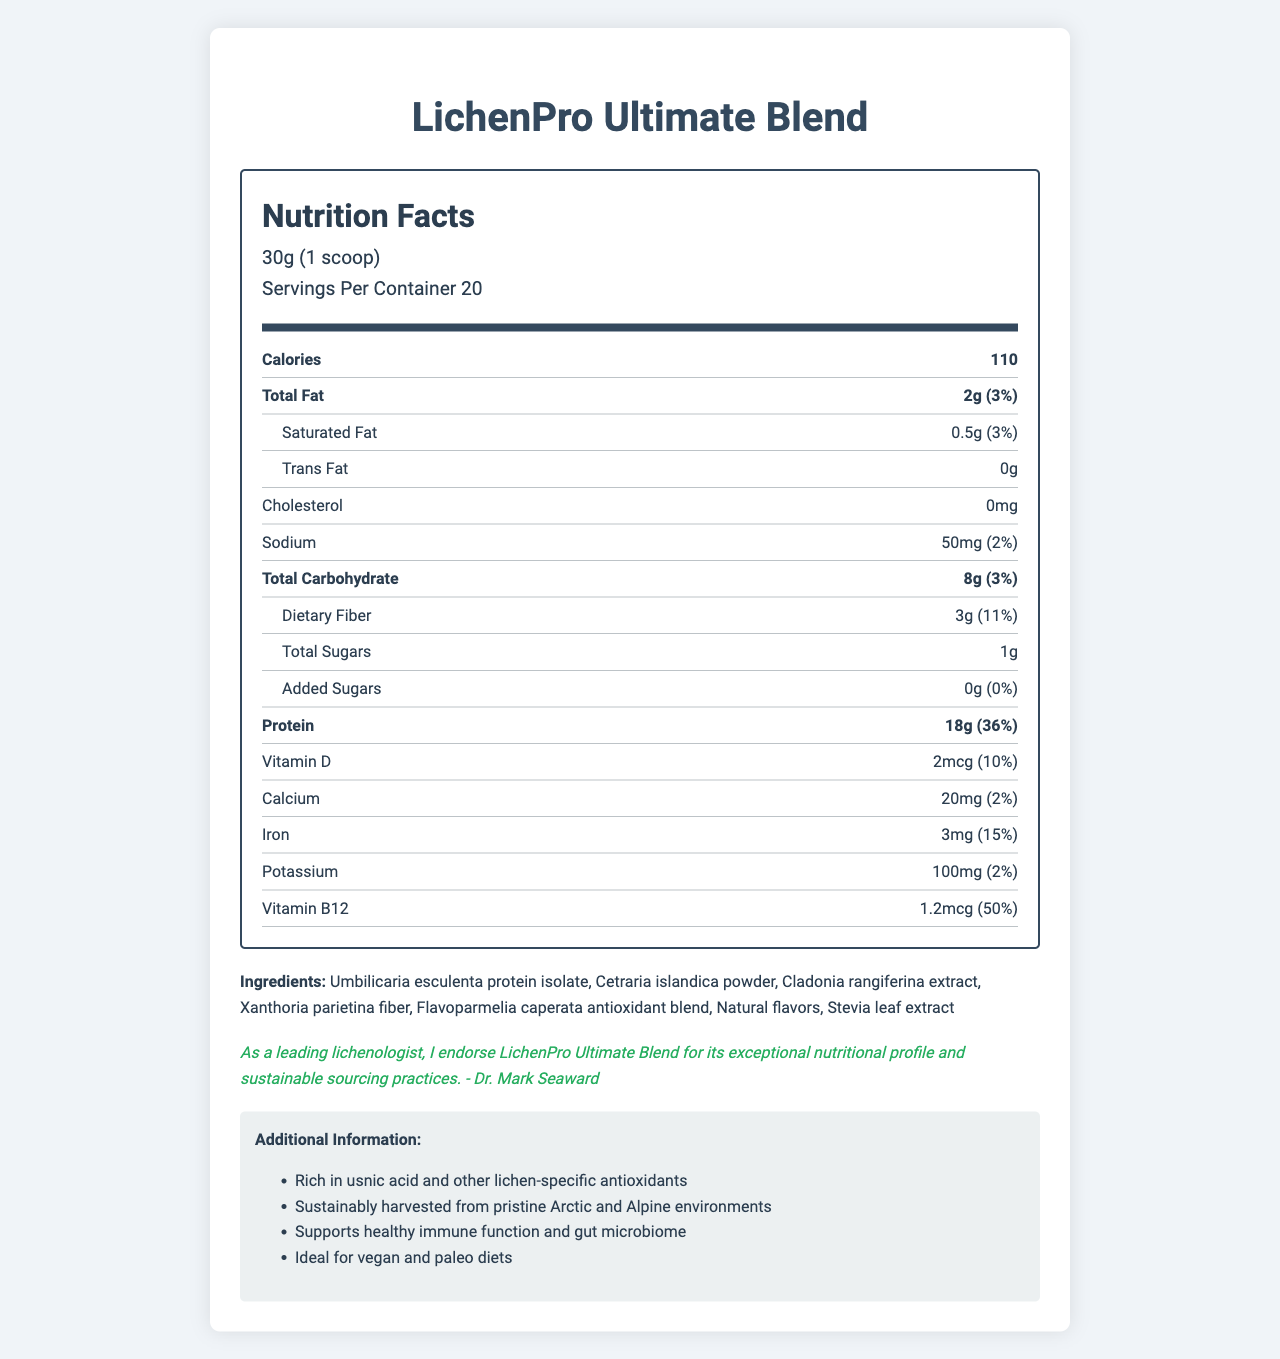what is the serving size of the LichenPro Ultimate Blend? The serving size is explicitly mentioned as "30g (1 scoop)."
Answer: 30g (1 scoop) how many servings are there in one container of LichenPro Ultimate Blend? The document states, "Servings Per Container 20."
Answer: 20 what is the total fat content in one serving of LichenPro Ultimate Blend? The total fat content is listed as "2g."
Answer: 2g how much protein does one serving of LichenPro Ultimate Blend contain? It is stated that the protein content is "18g" per serving.
Answer: 18g what are the primary ingredients in LichenPro Ultimate Blend? All these items are listed under the "Ingredients" section.
Answer: Umbilicaria esculenta protein isolate, Cetraria islandica powder, Cladonia rangiferina extract, Xanthoria parietina fiber, Flavoparmelia caperata antioxidant blend, Natural flavors, Stevia leaf extract does LichenPro Ultimate Blend contain any cholesterol? The document shows "Cholesterol: 0mg," indicating no cholesterol.
Answer: No how much vitamin B12 is in one serving of LichenPro Ultimate Blend? The content of vitamin B12 is mentioned as "1.2mcg."
Answer: 1.2mcg what is the daily value percentage of dietary fiber for one serving of LichenPro Ultimate Blend? It is listed as "Daily Value 11%" for dietary fiber.
Answer: 11% according to the endorsement, who supports LichenPro Ultimate Blend and why? The endorsement by Dr. Mark Seaward states that he supports the product for its nutritional profile and sustainable sourcing.
Answer: Dr. Mark Seaward supports LichenPro Ultimate Blend for its exceptional nutritional profile and sustainable sourcing practices how should LichenPro Ultimate Blend be stored? Storage instructions state it should be stored "in a cool, dry place away from direct sunlight."
Answer: In a cool, dry place away from direct sunlight which vitamin in LichenPro Ultimate Blend has the highest daily value percentage? A. Vitamin D B. Calcium C. Iron D. Vitamin B12 Vitamin B12 has a daily value percentage of 50%, which is the highest.
Answer: D. Vitamin B12 what is the calorie count per serving in LichenPro Ultimate Blend? A. 80 calories B. 90 calories C. 110 calories D. 150 calories The document lists the calorie count as 110 calories per serving.
Answer: C. 110 calories is LichenPro Ultimate Blend produced in a soy-free facility? The allergen information states, "Produced in a facility that also processes tree nuts and soy."
Answer: No summarize the key nutritional components and additional benefits of LichenPro Ultimate Blend. This summary encapsulates the nutritional values, ingredients, endorsement by Dr. Mark Seaward, and additional information about the product benefits and ideal diets.
Answer: The LichenPro Ultimate Blend provides 110 calories and 18g of protein per 30g serving. It contains low total fat (2g), saturated fat (0.5g), no trans fat, no cholesterol, and 50mg of sodium. It includes dietary fiber (3g), and minimal sugars (1g) with no added sugars. Additionally, it offers various vitamins and minerals, such as Vitamin D (2mcg), Calcium (20mg), Iron (3mg), Potassium (100mg), and Vitamin B12 (1.2mcg). Endorsed by Dr. Mark Seaward for its nutritional value and sustainable sourcing, the blend is rich in unique lichen antioxidants, supports immune function and gut health, and is suitable for vegan and paleo diets. what is the primary source of protein in LichenPro Ultimate Blend? The first ingredient listed under "Ingredients" is "Umbilicaria esculenta protein isolate," indicating it is the primary protein source.
Answer: Umbilicaria esculenta protein isolate does LichenPro Ultimate Blend support vegan diets? The additional information specifies that the blend is "Ideal for vegan and paleo diets."
Answer: Yes what is the exact amount of sugars added to LichenPro Ultimate Blend? Under added sugars, it is specified as "0g."
Answer: 0g 